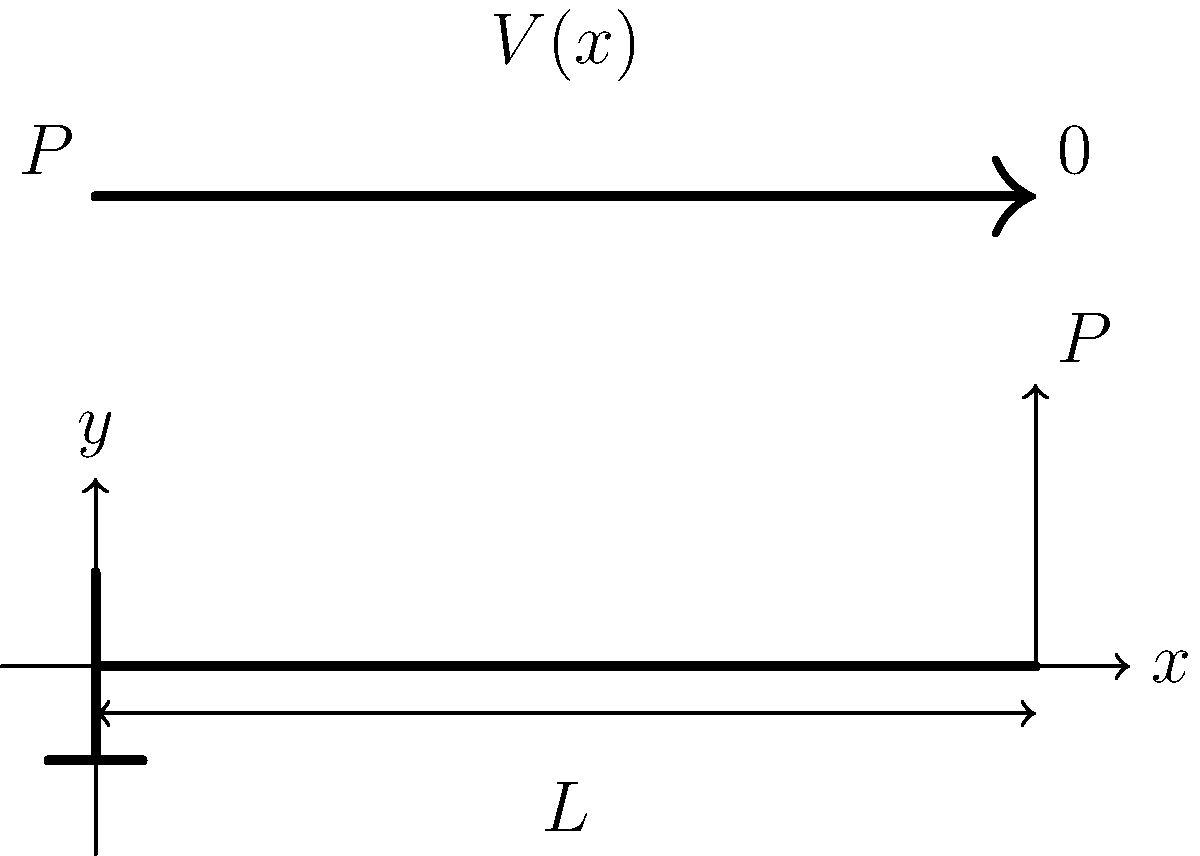A cantilever beam of length $L$ is subjected to a point load $P$ at its free end. Determine the expression for the shear force $V(x)$ at any point $x$ along the beam's length, where $x$ is measured from the fixed end. Also, sketch the shear force diagram. Let's approach this step-by-step:

1) First, let's consider the equilibrium of the beam. The reaction force at the fixed end must equal the applied load $P$ for vertical equilibrium.

2) Now, let's consider a section of the beam at distance $x$ from the fixed end. The shear force at this point, $V(x)$, is the internal force that balances the external forces on either side of the section.

3) To determine $V(x)$, we can consider the free body diagram of the portion of the beam from $x$ to $L$:
   - This portion has a length of $(L-x)$
   - It is subjected to the point load $P$ at its right end

4) For this portion to be in equilibrium, the shear force $V(x)$ must be equal and opposite to the applied load $P$. Therefore:

   $V(x) = P$

5) This expression is valid for all $x$ from 0 to $L$, because the point load is applied at the free end.

6) The shear force diagram will be a horizontal line at $V = P$ from $x = 0$ to $x = L$.

7) At $x = L$ (the free end), the shear force drops to zero, as there are no forces beyond this point.

Therefore, the shear force distribution can be expressed as:

$$V(x) = \begin{cases} 
P & \text{for } 0 \leq x < L \\
0 & \text{for } x = L
\end{cases}$$

The shear force diagram is a constant value $P$ from the fixed end to just before the free end, then drops to zero at the free end.
Answer: $V(x) = P$ for $0 \leq x < L$, $V(L) = 0$ 